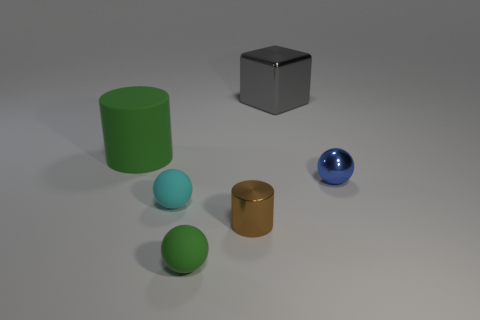What is the color of the big thing that is right of the rubber thing that is left of the tiny cyan ball?
Provide a succinct answer. Gray. What number of blocks are either gray objects or green matte things?
Your response must be concise. 1. How many green things are on the left side of the tiny matte object that is in front of the small matte object that is behind the green ball?
Offer a terse response. 1. There is a ball that is the same color as the rubber cylinder; what size is it?
Offer a very short reply. Small. Is there a tiny brown thing made of the same material as the tiny brown cylinder?
Offer a very short reply. No. Do the gray block and the tiny cyan thing have the same material?
Ensure brevity in your answer.  No. There is a large object that is to the right of the big rubber cylinder; what number of blue objects are in front of it?
Your response must be concise. 1. What number of purple things are small matte cubes or large things?
Give a very brief answer. 0. There is a large thing that is left of the green rubber thing right of the green matte thing on the left side of the cyan object; what is its shape?
Give a very brief answer. Cylinder. There is a metal thing that is the same size as the brown shiny cylinder; what is its color?
Keep it short and to the point. Blue. 